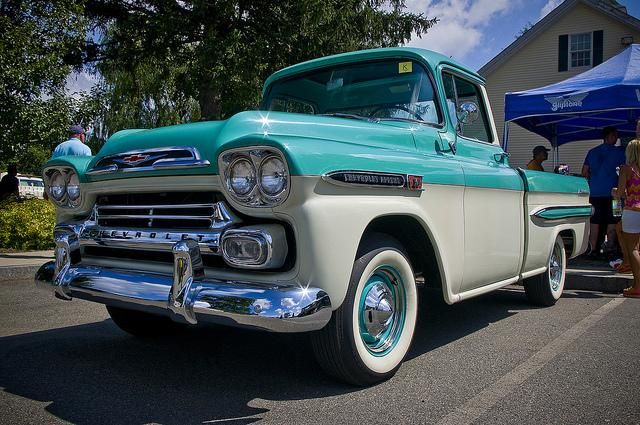What type of vehicle is shown? Please explain your reasoning. car. It's a shorter vehicle and has the common features of a car. 